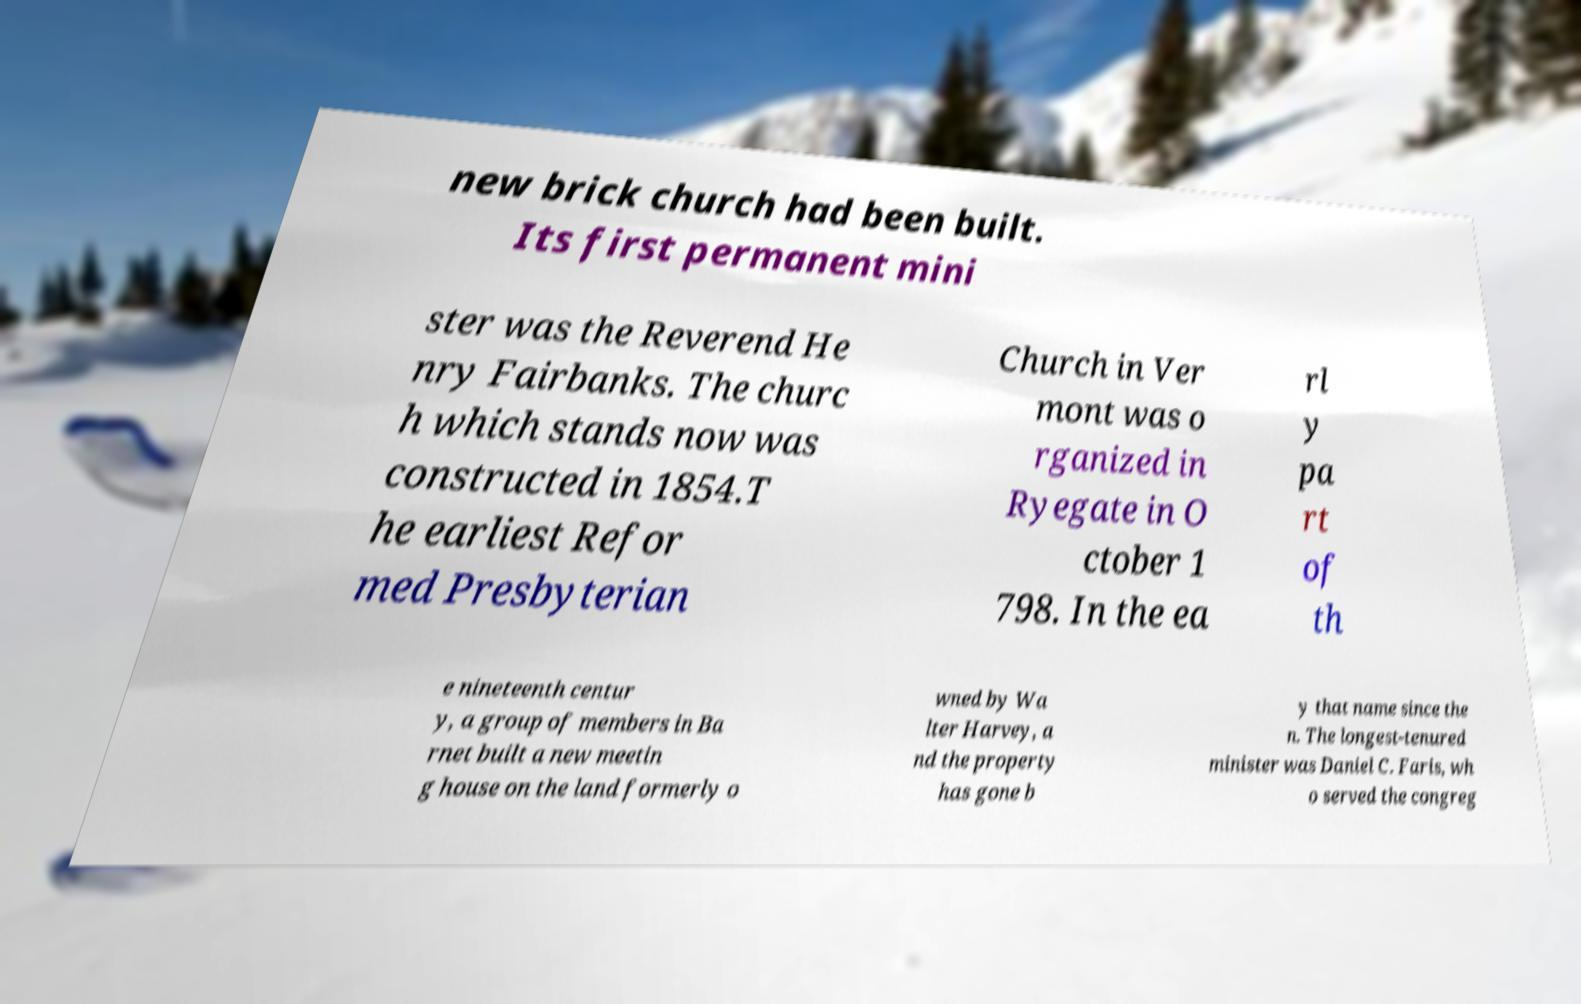I need the written content from this picture converted into text. Can you do that? new brick church had been built. Its first permanent mini ster was the Reverend He nry Fairbanks. The churc h which stands now was constructed in 1854.T he earliest Refor med Presbyterian Church in Ver mont was o rganized in Ryegate in O ctober 1 798. In the ea rl y pa rt of th e nineteenth centur y, a group of members in Ba rnet built a new meetin g house on the land formerly o wned by Wa lter Harvey, a nd the property has gone b y that name since the n. The longest-tenured minister was Daniel C. Faris, wh o served the congreg 